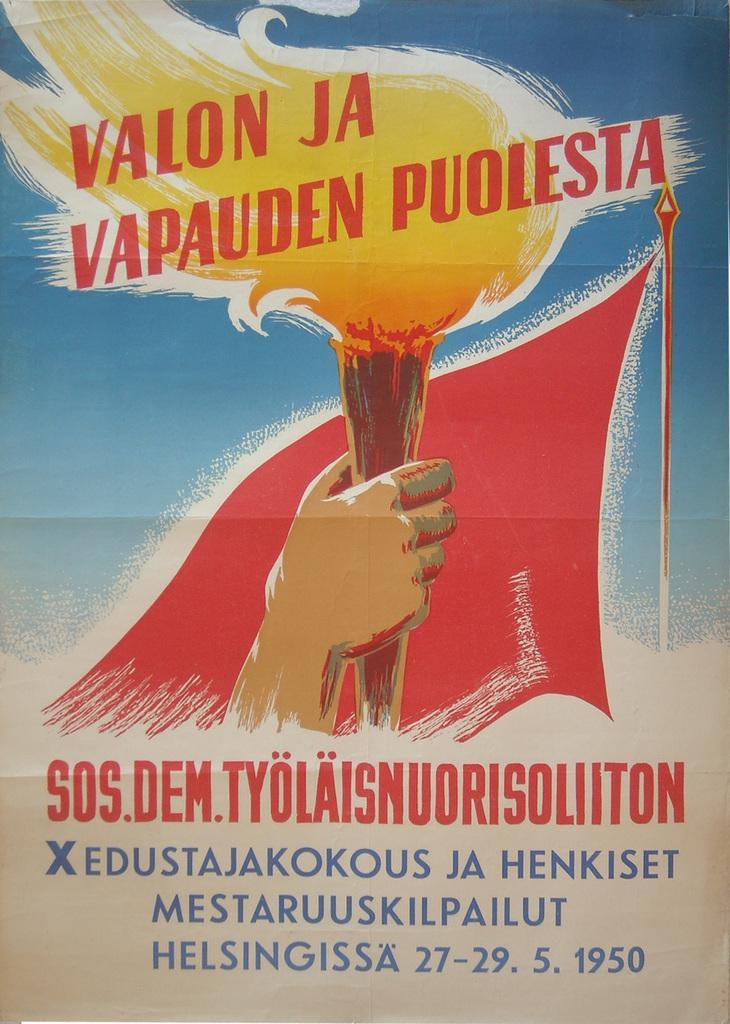How would you summarize this image in a sentence or two? In this image, this looks like a painting on the poster. I can see a person's hand holding a torch fire stick. This is a flag, which is red in color. These are the letters on the poster. 